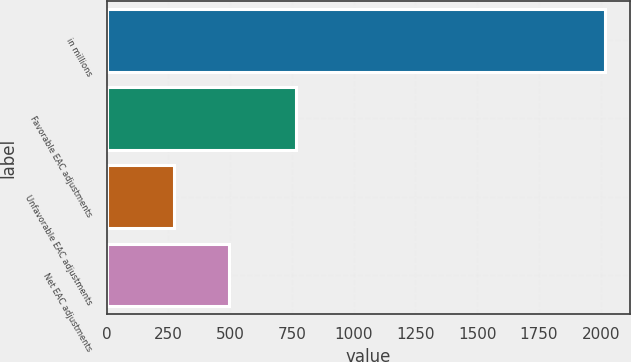Convert chart. <chart><loc_0><loc_0><loc_500><loc_500><bar_chart><fcel>in millions<fcel>Favorable EAC adjustments<fcel>Unfavorable EAC adjustments<fcel>Net EAC adjustments<nl><fcel>2016<fcel>765<fcel>271<fcel>494<nl></chart> 